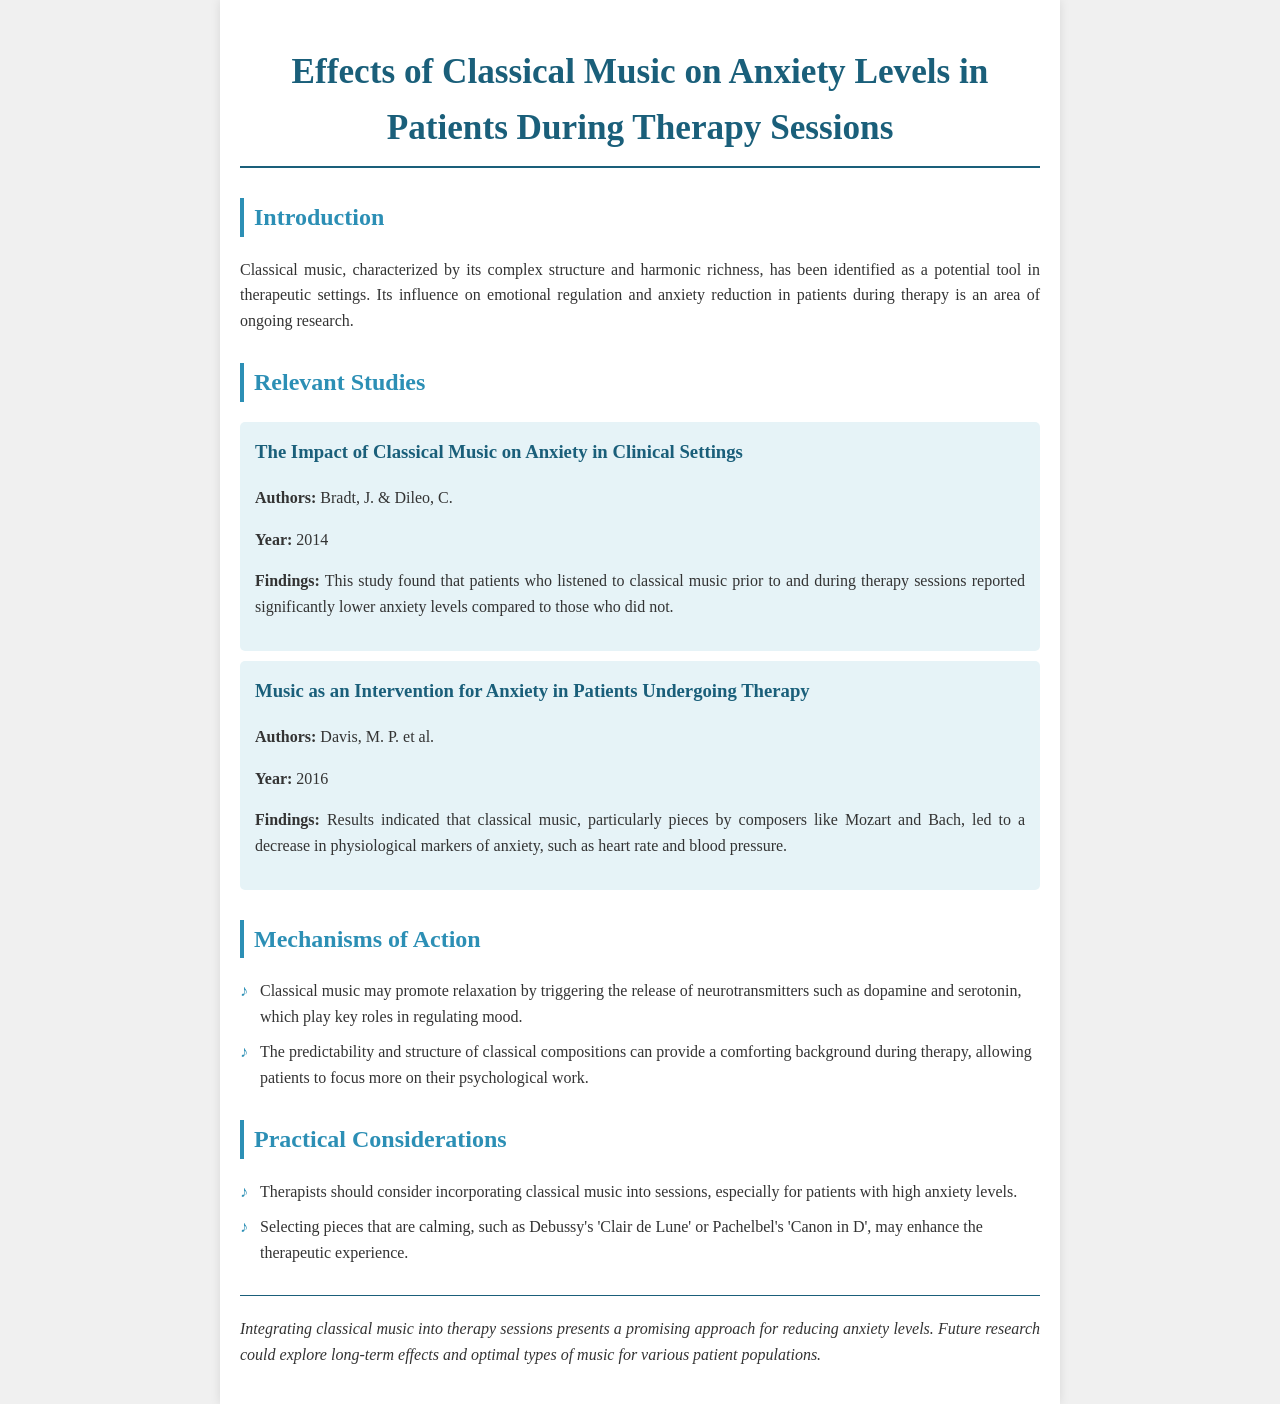What is the title of the document? The title of the document is presented prominently at the top, stating the focus of the research.
Answer: Effects of Classical Music on Anxiety Levels in Patients During Therapy Sessions Who are the authors of the first study mentioned? The document lists the authors of the first study in the relevant studies section.
Answer: Bradt, J. & Dileo, C What year was the second study published? The publication year of the second study is provided alongside the study's details.
Answer: 2016 What outcome did classical music have on patients according to the first study? The findings section of the first study outlines the main result regarding patient anxiety levels.
Answer: Lower anxiety levels What neurotransmitters are mentioned as being influenced by classical music? The mechanisms of action section lists specific neurotransmitters related to mood regulation affected by music.
Answer: Dopamine and serotonin Which two composers are highlighted as particularly beneficial for anxiety reduction? The practical considerations section specifies composers whose music is noted for calming effects.
Answer: Mozart and Bach What type of music should therapists consider using according to the document? The document provides recommendations for the type of music that may enhance therapeutic experience.
Answer: Classical music What is suggested as a future research focus? The conclusion section suggests areas for further exploration related to the use of classical music in therapy.
Answer: Long-term effects and optimal types of music 